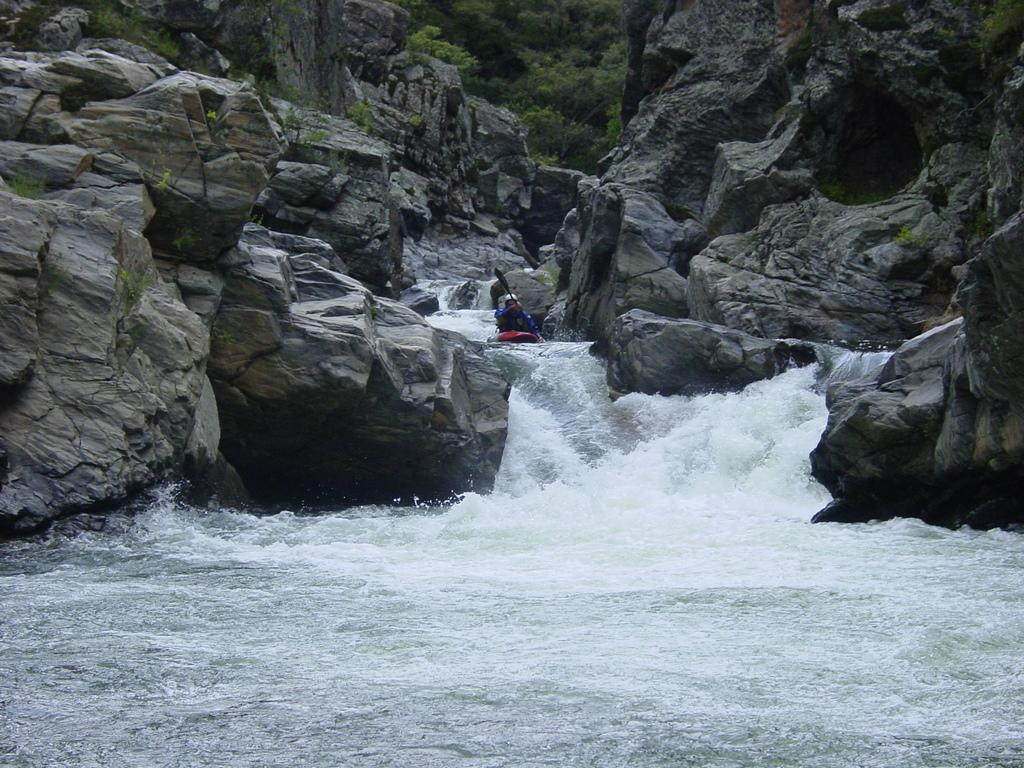Who is in the image? There is a person in the image. What is the person doing in the image? The person is riding a boat. What is the person using to propel the boat? The person is holding a paddle. What type of environment is depicted in the image? There is water, rocks, and trees in the image. What is the person's reaction to the police in the image? There is no mention of police in the image, so it is not possible to determine the person's reaction. 